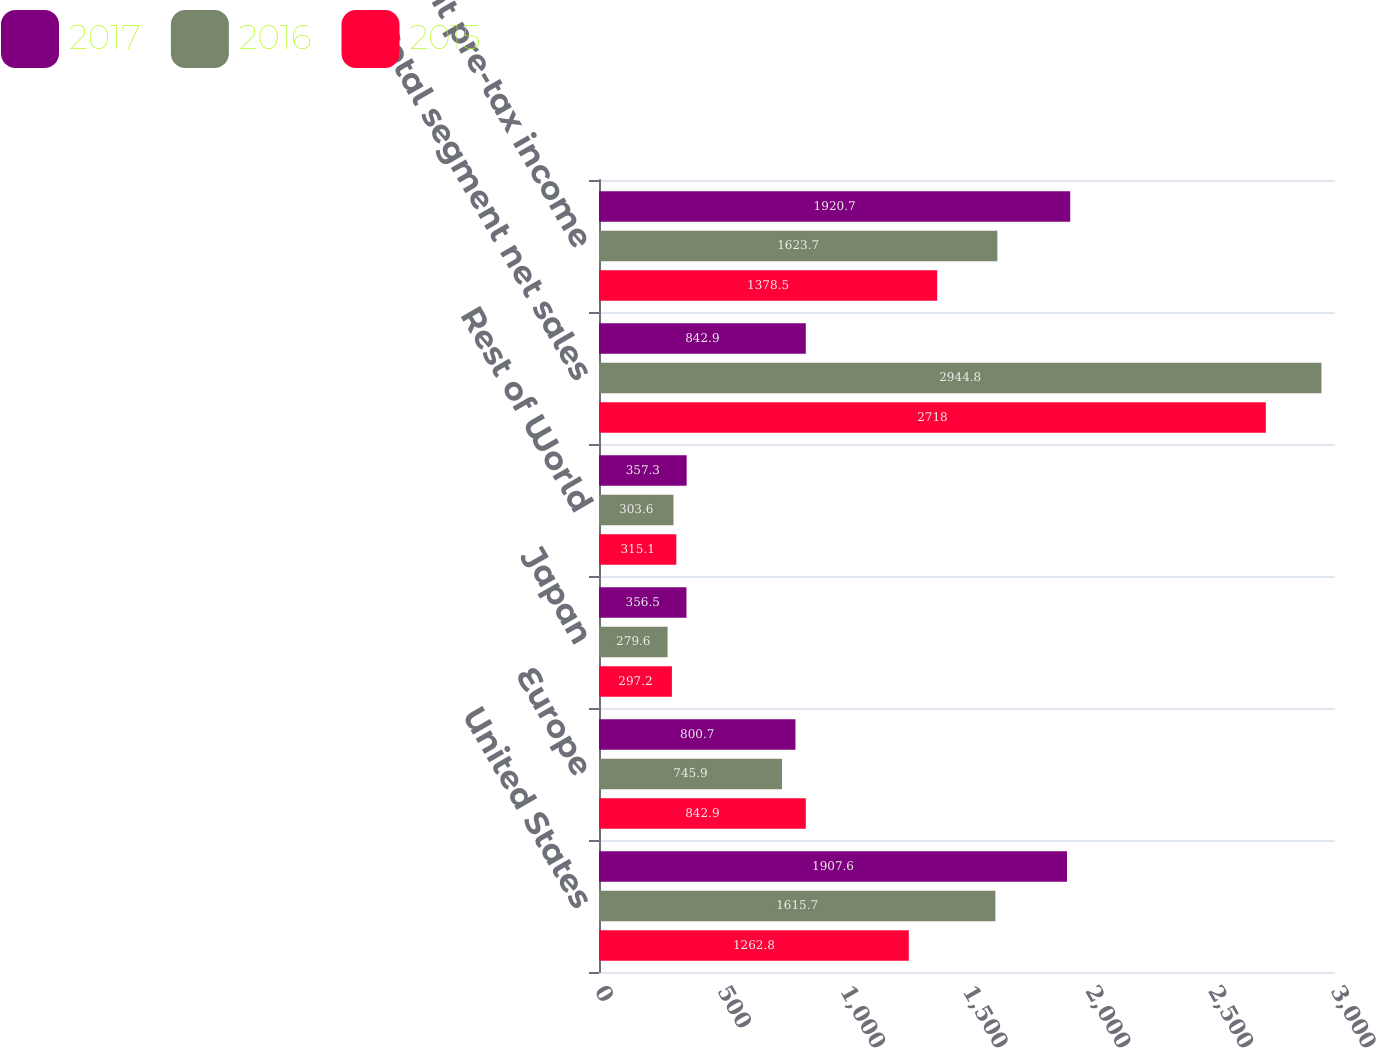<chart> <loc_0><loc_0><loc_500><loc_500><stacked_bar_chart><ecel><fcel>United States<fcel>Europe<fcel>Japan<fcel>Rest of World<fcel>Total segment net sales<fcel>Total segment pre-tax income<nl><fcel>2017<fcel>1907.6<fcel>800.7<fcel>356.5<fcel>357.3<fcel>842.9<fcel>1920.7<nl><fcel>2016<fcel>1615.7<fcel>745.9<fcel>279.6<fcel>303.6<fcel>2944.8<fcel>1623.7<nl><fcel>2015<fcel>1262.8<fcel>842.9<fcel>297.2<fcel>315.1<fcel>2718<fcel>1378.5<nl></chart> 